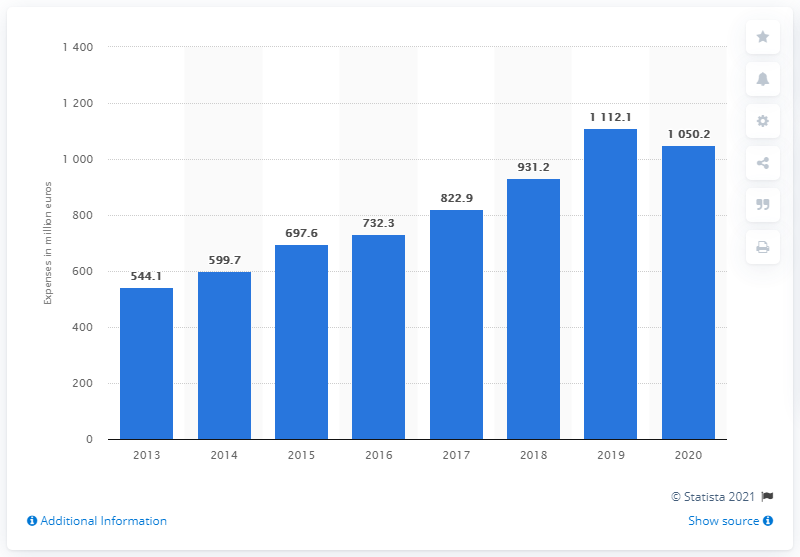Specify some key components in this picture. According to the provided information, Puma spent 1050.2 million on marketing in 2020. 